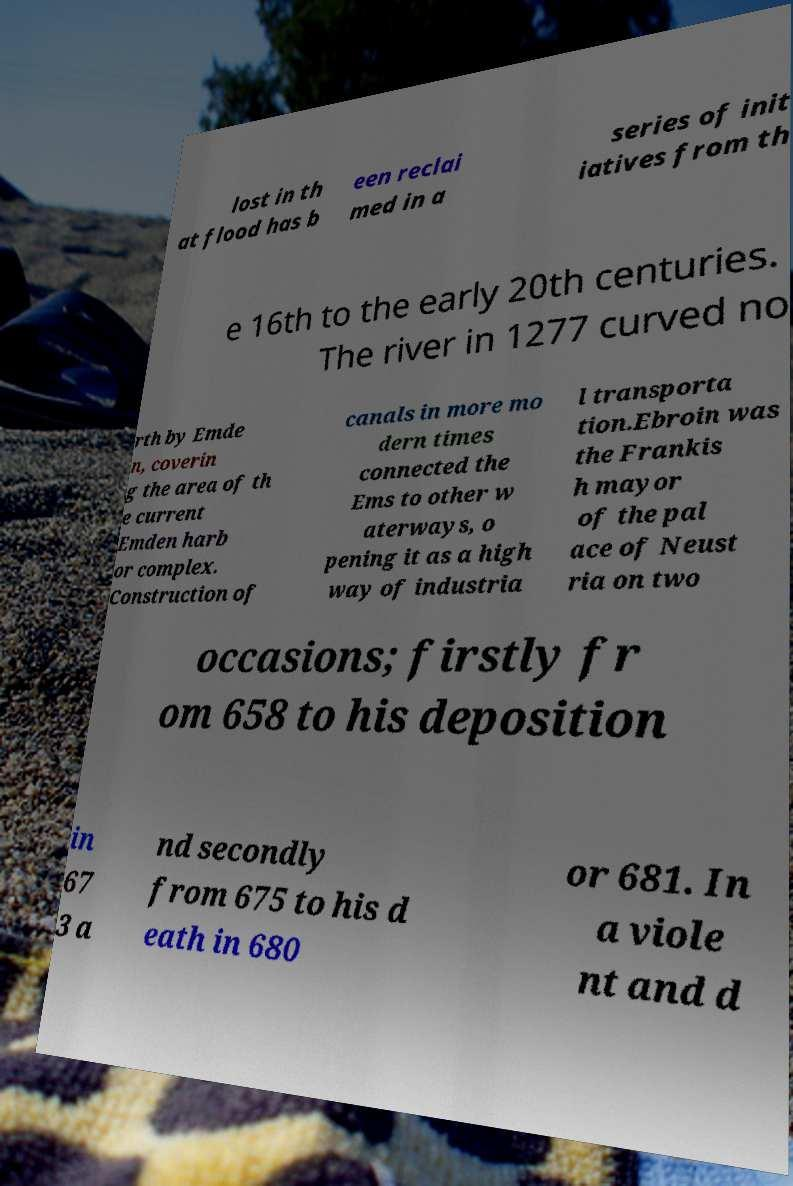Can you accurately transcribe the text from the provided image for me? lost in th at flood has b een reclai med in a series of init iatives from th e 16th to the early 20th centuries. The river in 1277 curved no rth by Emde n, coverin g the area of th e current Emden harb or complex. Construction of canals in more mo dern times connected the Ems to other w aterways, o pening it as a high way of industria l transporta tion.Ebroin was the Frankis h mayor of the pal ace of Neust ria on two occasions; firstly fr om 658 to his deposition in 67 3 a nd secondly from 675 to his d eath in 680 or 681. In a viole nt and d 